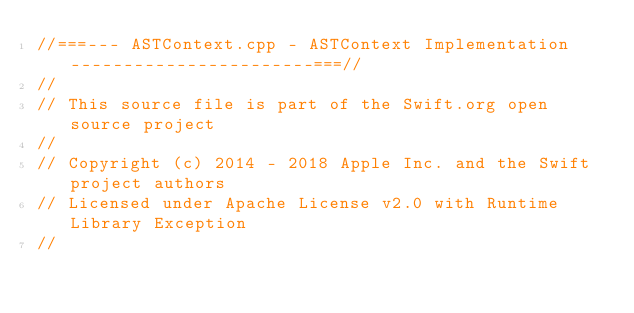<code> <loc_0><loc_0><loc_500><loc_500><_C++_>//===--- ASTContext.cpp - ASTContext Implementation -----------------------===//
//
// This source file is part of the Swift.org open source project
//
// Copyright (c) 2014 - 2018 Apple Inc. and the Swift project authors
// Licensed under Apache License v2.0 with Runtime Library Exception
//</code> 